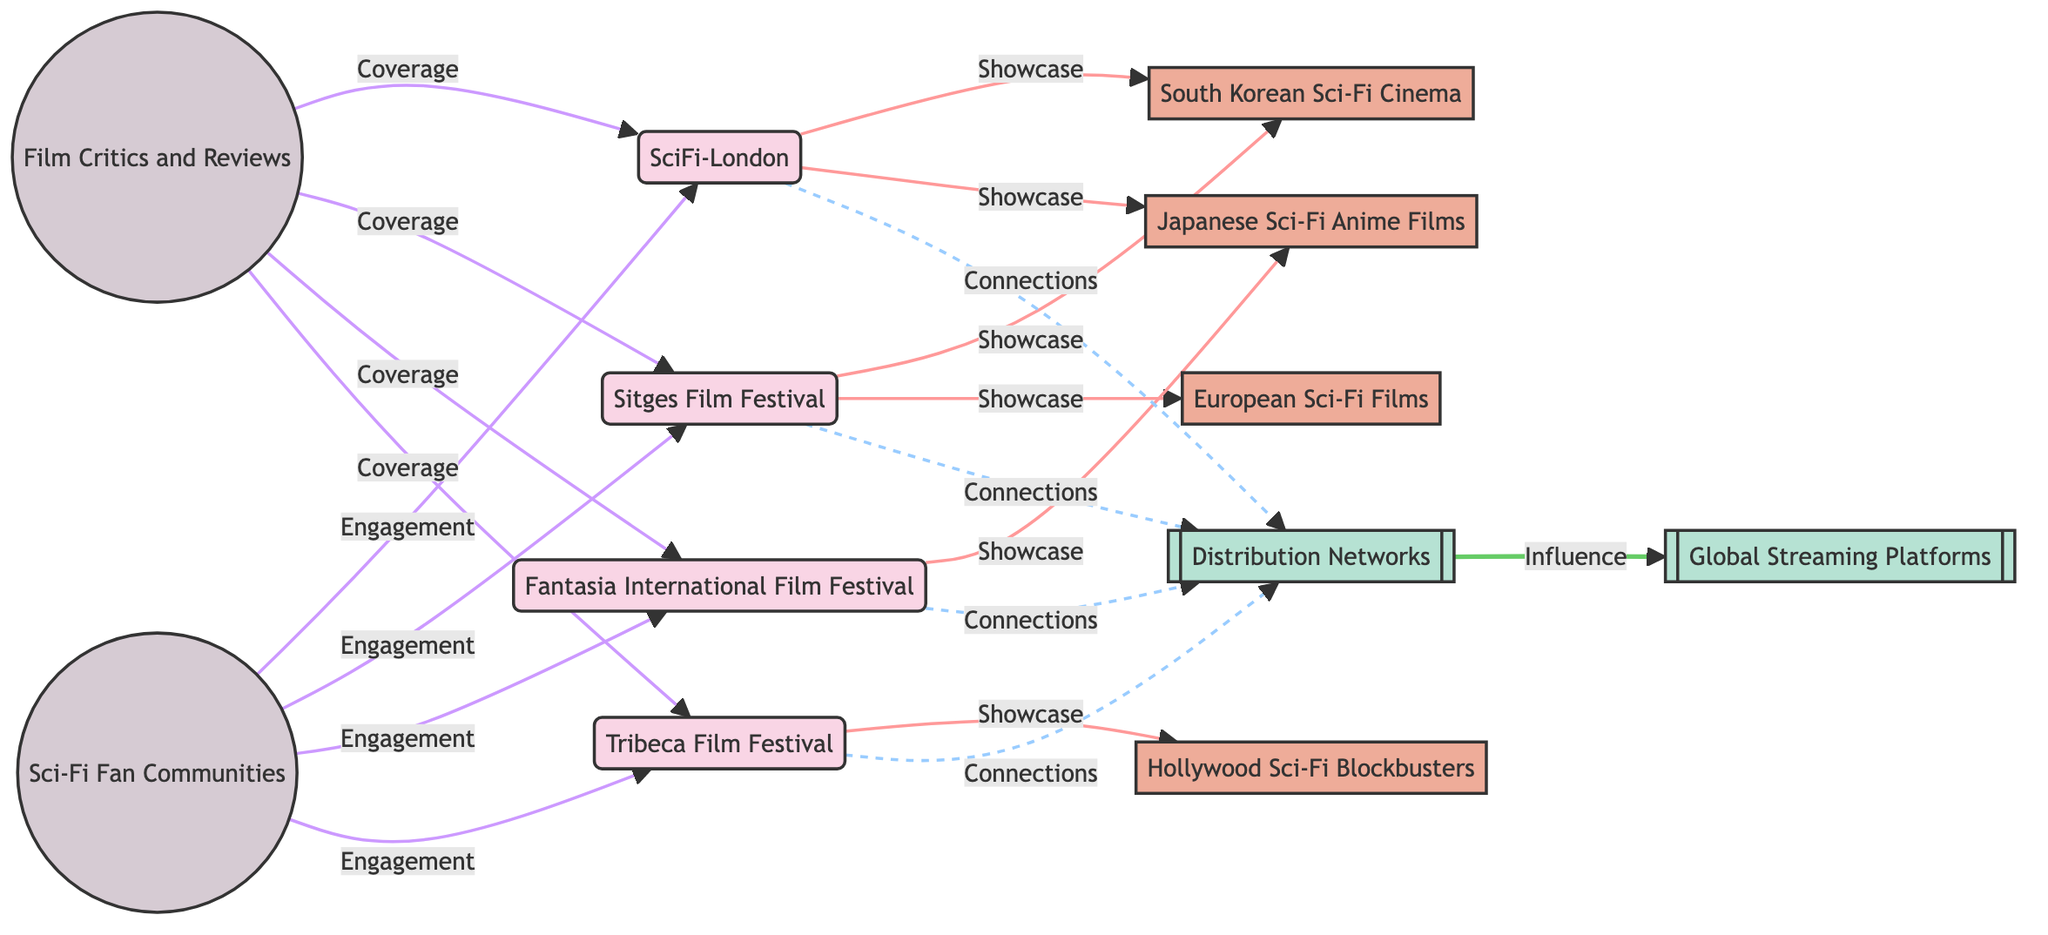What are the key film festivals showcased in the diagram? The diagram lists Sci-Fi-London, Sitges Film Festival, Fantasia International Film Festival, and Tribeca Film Festival as the key film festivals involved.
Answer: Sci-Fi-London, Sitges Film Festival, Fantasia International Film Festival, Tribeca Film Festival How many regional focuses are depicted? There are four regional focuses illustrated in the diagram: South Korean Sci-Fi Cinema, Japanese Sci-Fi Anime Films, Hollywood Sci-Fi Blockbusters, and European Sci-Fi Films.
Answer: 4 What type of relationship do the film festivals have with the Distribution Networks? The film festivals have a "Connections" relationship with the Distribution Networks, indicating a link or association between them.
Answer: Connections Which film festival showcases Japanese Sci-Fi Anime Films? According to the diagram, Fantasia International Film Festival is specifically noted for showcasing Japanese Sci-Fi Anime Films.
Answer: Fantasia International Film Festival Which resource influences the Global Streaming Platforms? The Distribution Networks are shown as the influencing resource that connects to the Global Streaming Platforms, highlighting their role in the global distribution process.
Answer: Distribution Networks Identify the community connected to Sci-Fi-London. Film Critics and Sci-Fi Fan Communities are connected to Sci-Fi-London, emphasizing the engagement and coverage that the festival receives.
Answer: Film Critics, Sci-Fi Fan Communities Which regional focus is associated with the Tribeca Film Festival? The Tribeca Film Festival is associated with Hollywood Sci-Fi Blockbusters, indicating its focus on showcasing this specific genre of films.
Answer: Hollywood Sci-Fi Blockbusters How many links involve the Sitges Film Festival? The Sitges Film Festival is involved in three links: showcasing South Korean Sci-Fi Cinema, showcasing European Sci-Fi Films, and having connections with Distribution Networks.
Answer: 3 What is the relationship type between Film Critics and the festivals? The relationship type is "Coverage," showing that Film Critics provide reviews or publicity for all four mentioned film festivals.
Answer: Coverage 